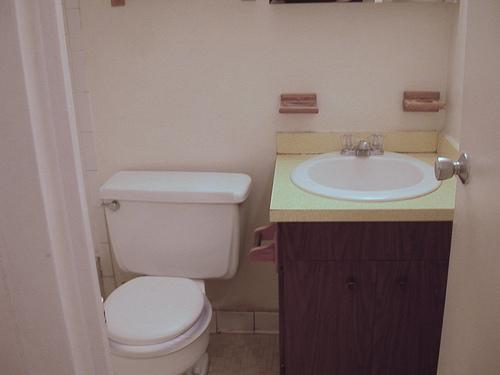How many soap dishes can be seen in the image, and where are they located? There are two soap dishes on the wall above the sink. Provide a concise description of the overall scene in the image. A clean bathroom with a white toilet, a sink with silver faucets, a wooden cabinet, and two soap dishes on the wall. Enumerate three contrasting elements of this image with respect to colors and materials. Silver faucet versus wooden cabinet, white ceramic toilet versus brown toilet paper holder, and chrome door knob versus white wall. What type of tile is present in the bathroom? White subway tile in the shower and patterned tile on the floor. What color are the handles of the sink faucets? The handles of the sink faucets are clear. Count the number of doors and faucets shown in the image. There are two doors and two faucets in the image. Explain any signs of wear or age in the image. There is mold along the edge of the tile, implying a need for maintenance. Mention the type of objects related to hygiene present in the bathroom. Toilet, sink, soap dishes, toilet paper holder, and a cup and toothbrush holder. Describe the state of the bathroom door in the image. The bathroom door is open with a chrome knob. Analyze the possible interaction between the toilet paper holder and the cabinet. The toilet paper holder is attached to the side of the wooden base cabinet, which allows for easy access to toilet paper while using the toilet. 